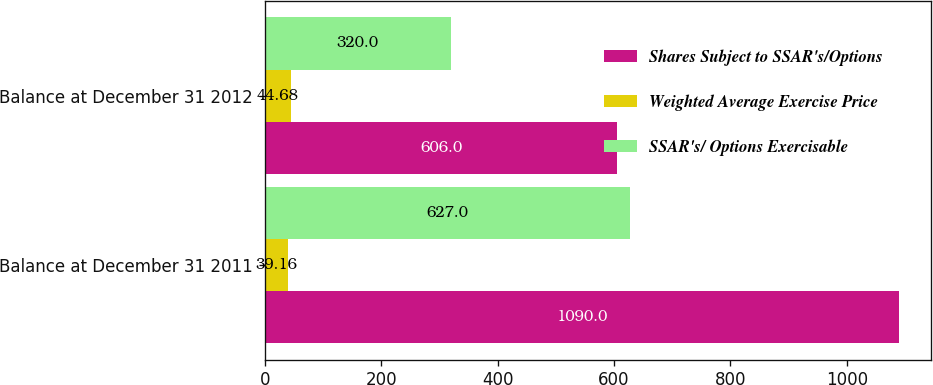Convert chart. <chart><loc_0><loc_0><loc_500><loc_500><stacked_bar_chart><ecel><fcel>Balance at December 31 2011<fcel>Balance at December 31 2012<nl><fcel>Shares Subject to SSAR's/Options<fcel>1090<fcel>606<nl><fcel>Weighted Average Exercise Price<fcel>39.16<fcel>44.68<nl><fcel>SSAR's/ Options Exercisable<fcel>627<fcel>320<nl></chart> 